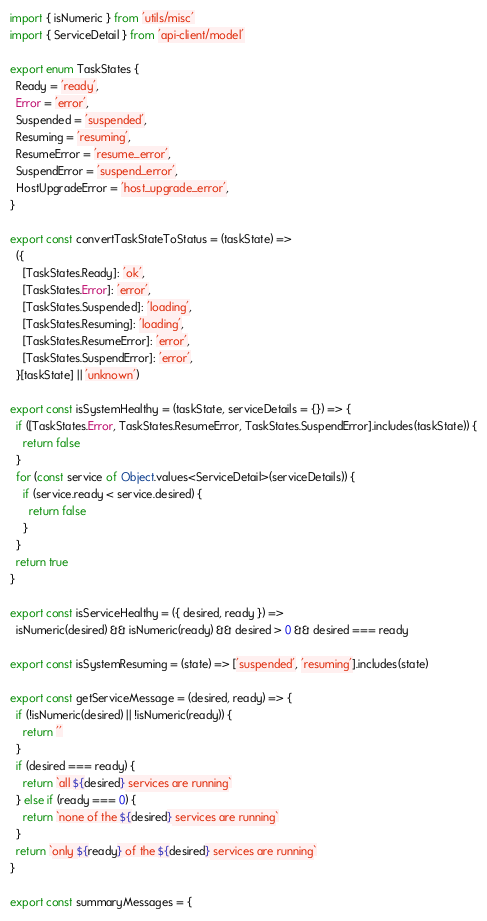<code> <loc_0><loc_0><loc_500><loc_500><_TypeScript_>import { isNumeric } from 'utils/misc'
import { ServiceDetail } from 'api-client/model'

export enum TaskStates {
  Ready = 'ready',
  Error = 'error',
  Suspended = 'suspended',
  Resuming = 'resuming',
  ResumeError = 'resume_error',
  SuspendError = 'suspend_error',
  HostUpgradeError = 'host_upgrade_error',
}

export const convertTaskStateToStatus = (taskState) =>
  ({
    [TaskStates.Ready]: 'ok',
    [TaskStates.Error]: 'error',
    [TaskStates.Suspended]: 'loading',
    [TaskStates.Resuming]: 'loading',
    [TaskStates.ResumeError]: 'error',
    [TaskStates.SuspendError]: 'error',
  }[taskState] || 'unknown')

export const isSystemHealthy = (taskState, serviceDetails = {}) => {
  if ([TaskStates.Error, TaskStates.ResumeError, TaskStates.SuspendError].includes(taskState)) {
    return false
  }
  for (const service of Object.values<ServiceDetail>(serviceDetails)) {
    if (service.ready < service.desired) {
      return false
    }
  }
  return true
}

export const isServiceHealthy = ({ desired, ready }) =>
  isNumeric(desired) && isNumeric(ready) && desired > 0 && desired === ready

export const isSystemResuming = (state) => ['suspended', 'resuming'].includes(state)

export const getServiceMessage = (desired, ready) => {
  if (!isNumeric(desired) || !isNumeric(ready)) {
    return ''
  }
  if (desired === ready) {
    return `all ${desired} services are running`
  } else if (ready === 0) {
    return `none of the ${desired} services are running`
  }
  return `only ${ready} of the ${desired} services are running`
}

export const summaryMessages = {</code> 